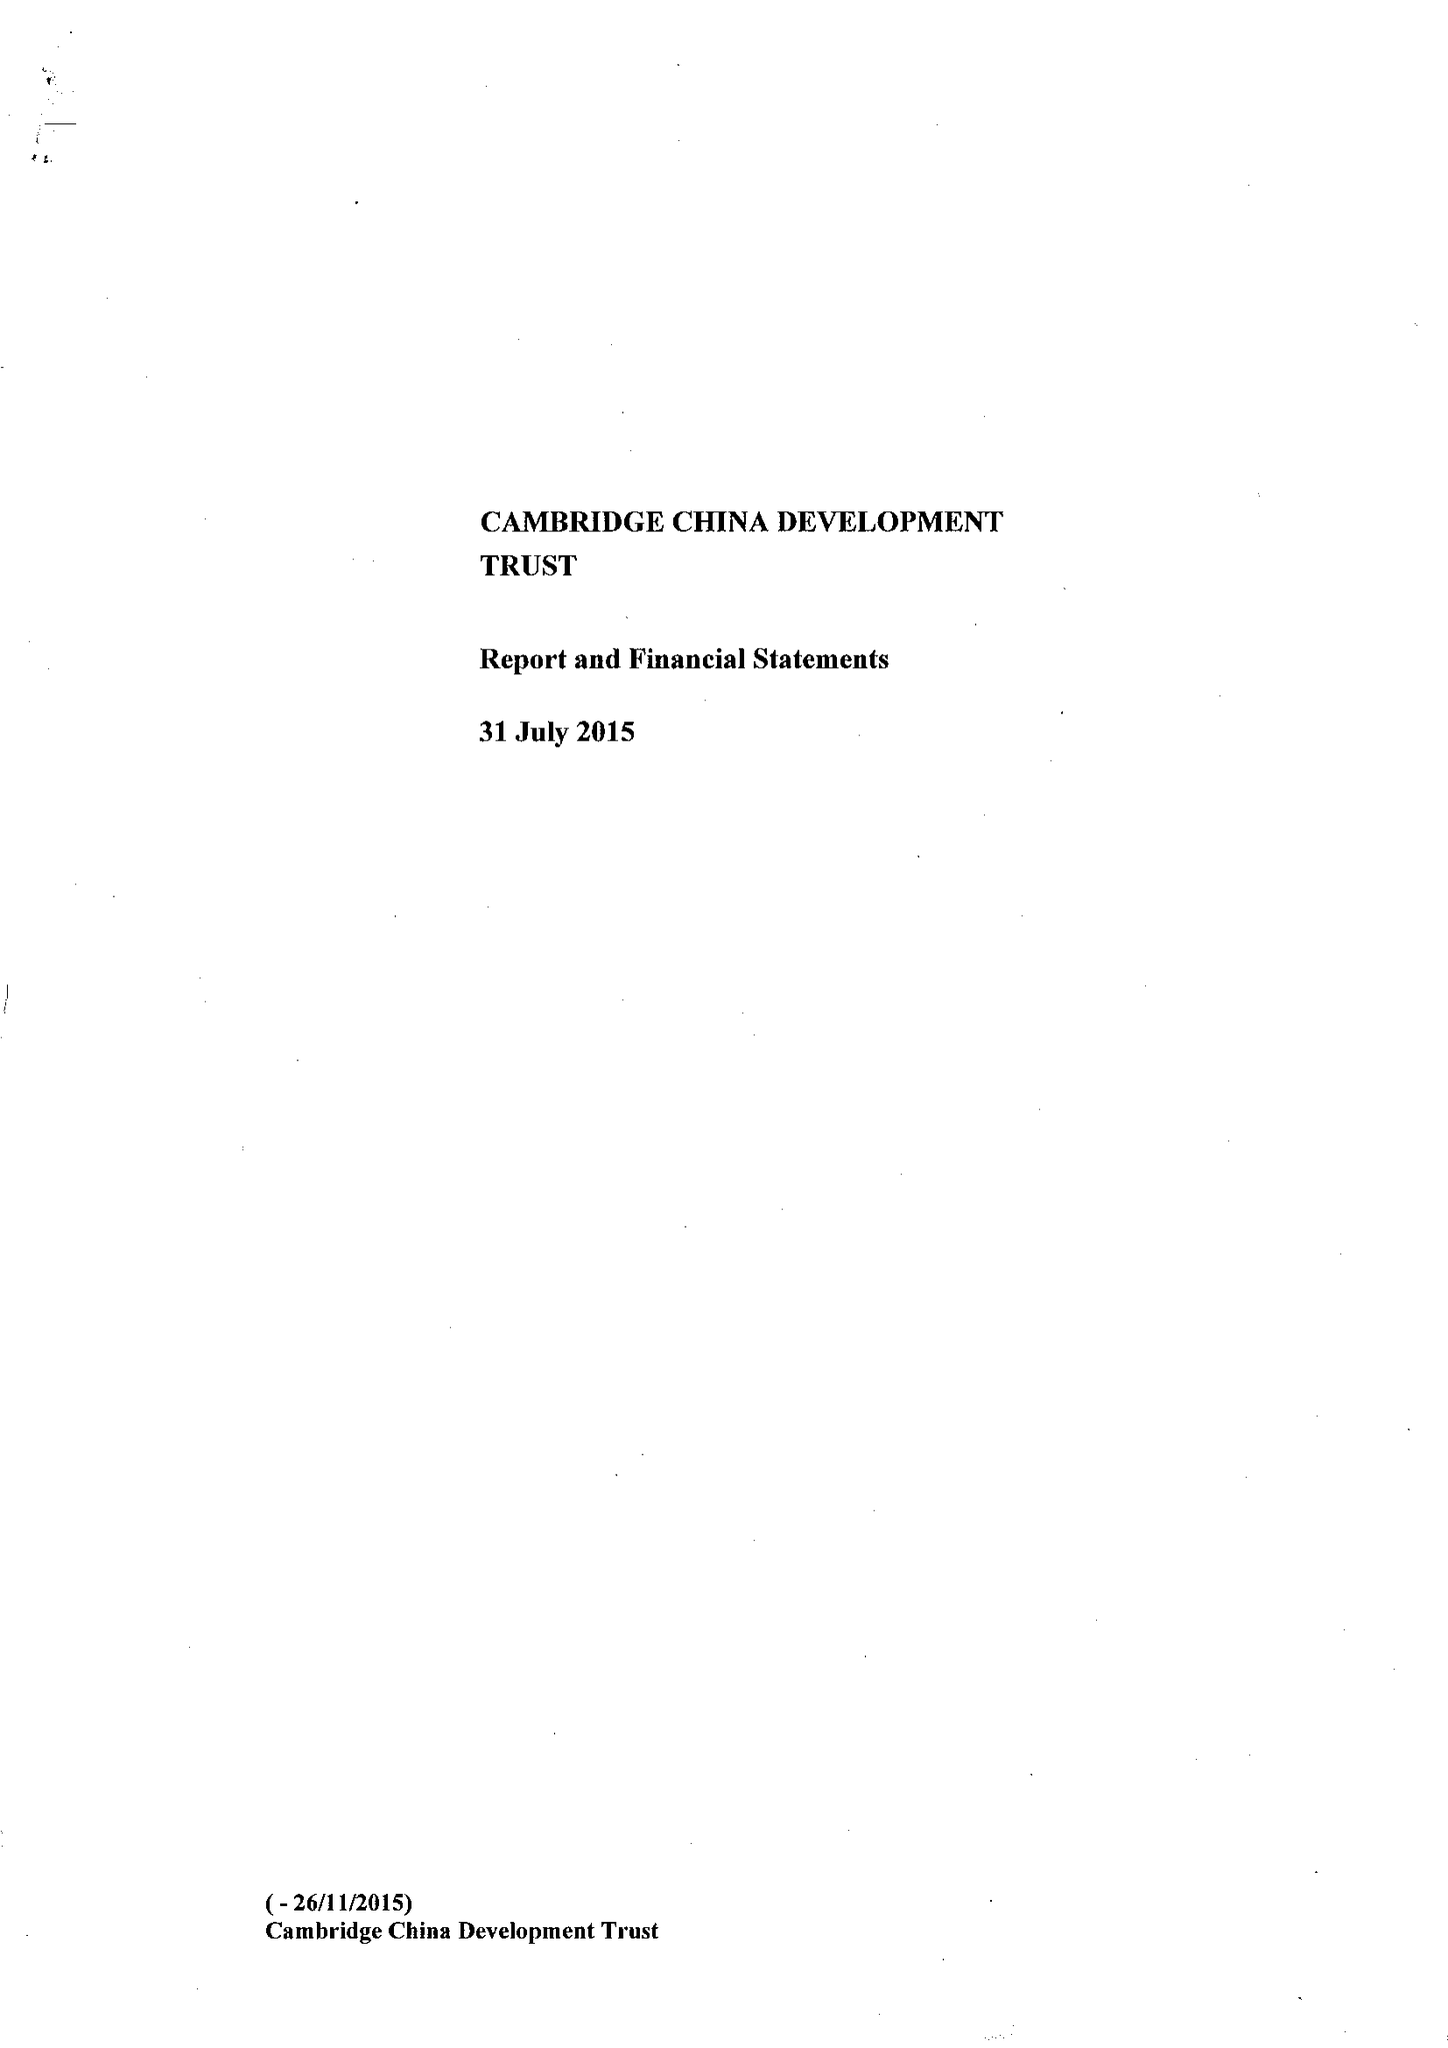What is the value for the address__postcode?
Answer the question using a single word or phrase. CB2 1TQ 